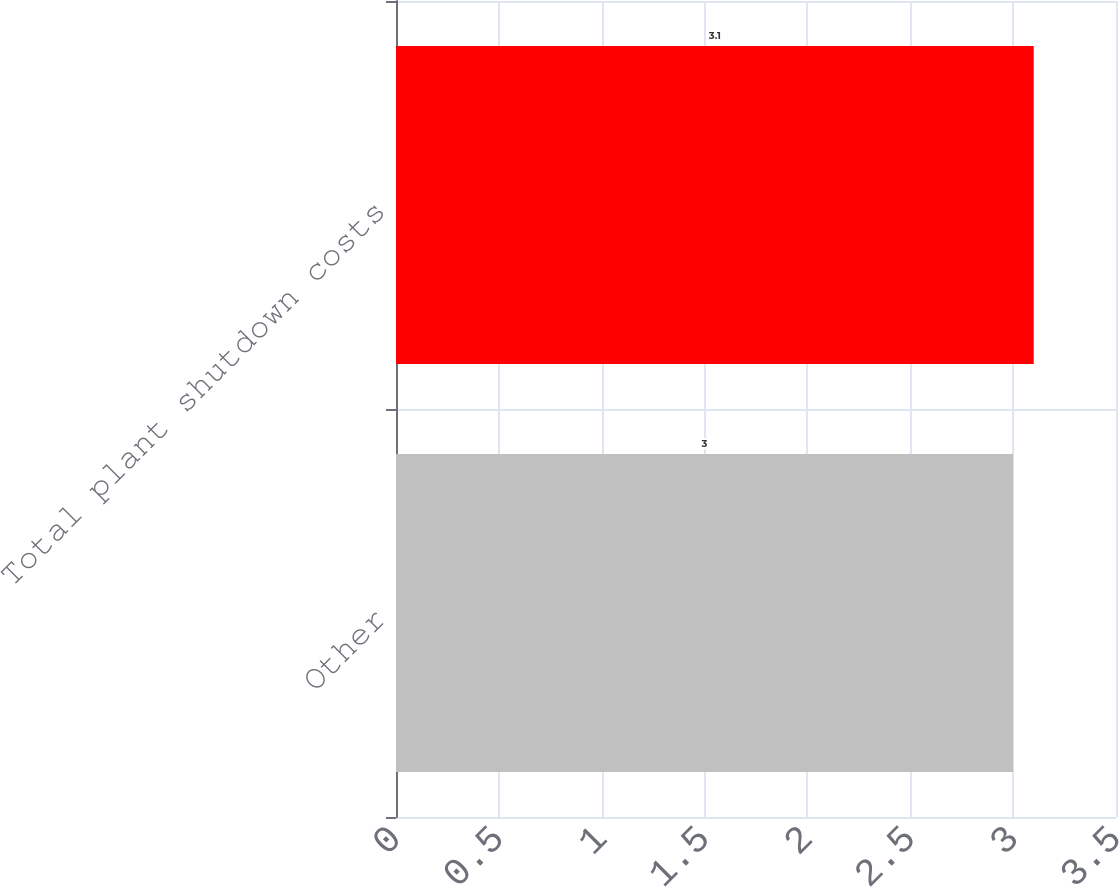Convert chart. <chart><loc_0><loc_0><loc_500><loc_500><bar_chart><fcel>Other<fcel>Total plant shutdown costs<nl><fcel>3<fcel>3.1<nl></chart> 